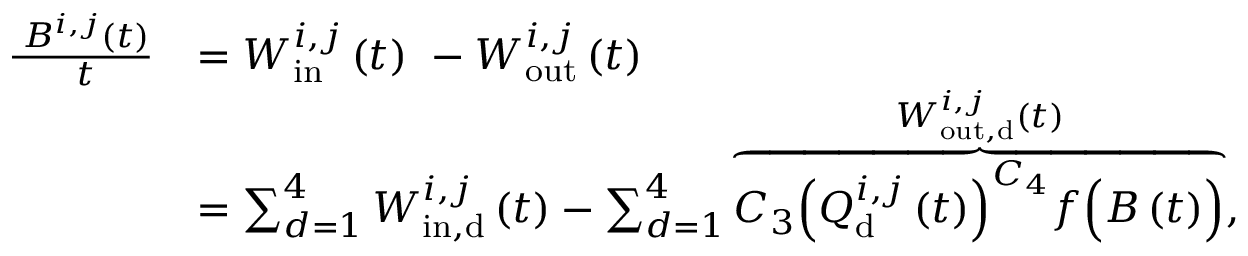Convert formula to latex. <formula><loc_0><loc_0><loc_500><loc_500>\begin{array} { r l } { \frac { \partial B ^ { i , j } ( t ) } { \partial t } } & { = W _ { i n } ^ { i , j } \left ( t \right ) \ - W _ { o u t } ^ { i , j } \left ( t \right ) } \\ & { = \sum _ { d = 1 } ^ { 4 } { W _ { i n , d } ^ { i , j } \left ( t \right ) } - \sum _ { d = 1 } ^ { 4 } { \overbrace { C _ { 3 } { \left ( Q _ { d } ^ { i , j } \left ( t \right ) \right ) } ^ { C _ { 4 } } f \left ( B \left ( t \right ) \right ) } ^ { W _ { o u t , d } ^ { i , j } \left ( t \right ) } , } } \end{array}</formula> 